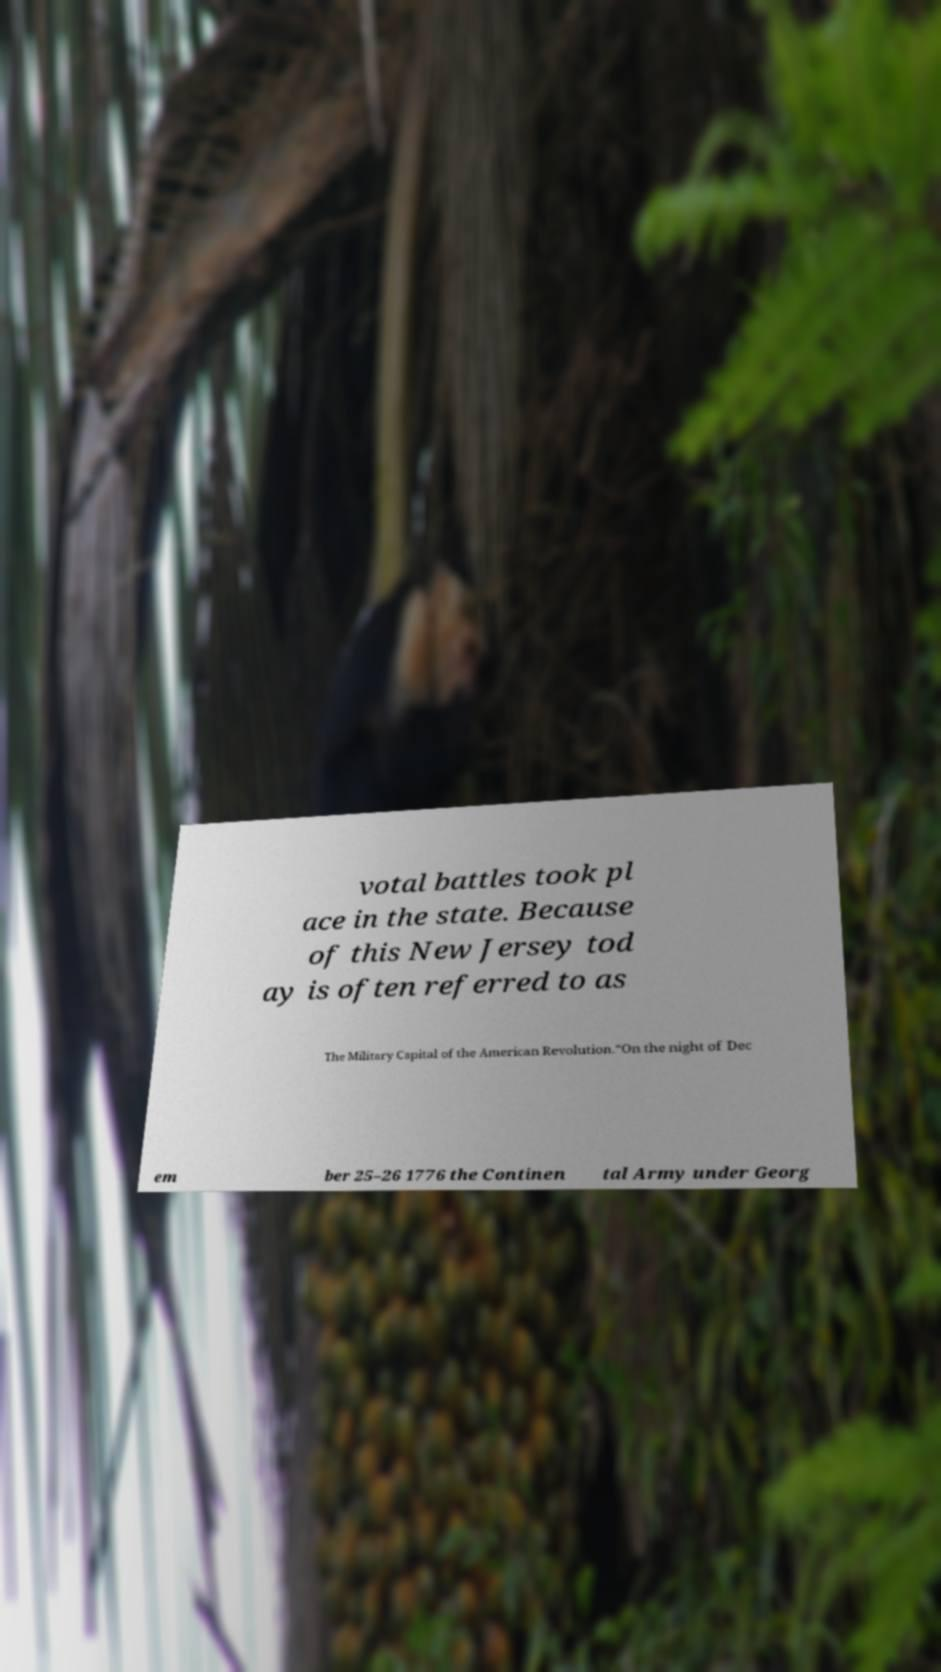Could you extract and type out the text from this image? votal battles took pl ace in the state. Because of this New Jersey tod ay is often referred to as The Military Capital of the American Revolution.“On the night of Dec em ber 25–26 1776 the Continen tal Army under Georg 